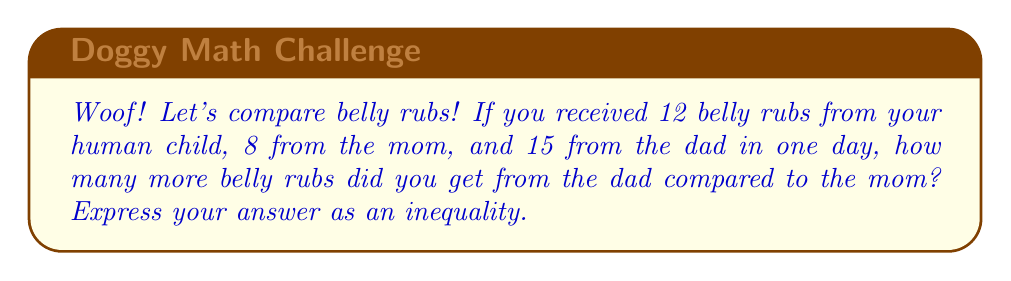Provide a solution to this math problem. Let's approach this step-by-step:

1. Identify the number of belly rubs from each family member:
   - Dad: 15 belly rubs
   - Mom: 8 belly rubs

2. To find how many more belly rubs you got from the dad compared to the mom, we need to subtract:
   $15 - 8 = 7$

3. Now, we can express this as an inequality:
   The number of belly rubs from dad is greater than the number of belly rubs from mom by 7.

4. In mathematical notation, we can write this as:
   $Dad's \text{ belly rubs} > Mom's \text{ belly rubs} + 7$

5. Or, using the actual numbers:
   $15 > 8 + 7$
Answer: $Dad's \text{ belly rubs} > Mom's \text{ belly rubs} + 7$ 